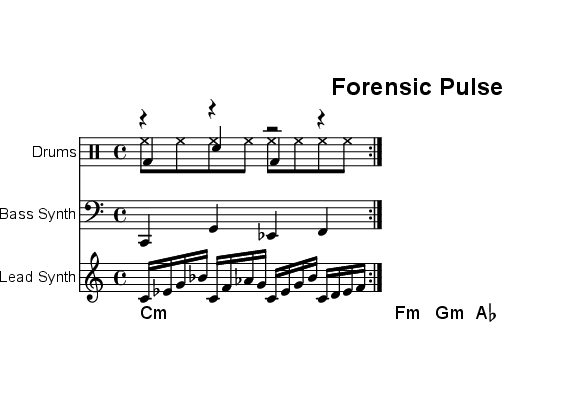What is the key signature of this music? The key signature is C minor, indicated by three flats in the music notation. These flats correspond to the notes B♭, E♭, and A♭. This can be confirmed by looking at the key signature shown at the beginning of the sheet music.
Answer: C minor What is the time signature of this piece? The time signature is 4/4, which means there are four beats in each measure and the quarter note gets one beat. This is straightforwardly indicated at the start of the sheet music.
Answer: 4/4 What is the tempo marking for the composition? The tempo marking is 128 beats per minute (BPM), specified in the tempo line. This indicates a moderately fast tempo, suitable for electronic music genres.
Answer: 128 How many measures does the kick drum part repeat? The kick drum part repeats for a total of two measures as indicated by the "repeat volta 2" notation, which specifies that the sequence within those measures is to be repeated twice.
Answer: 2 What type of synthesizer is used for the lead part? The lead part is played on a lead synth as indicated in the staff labeling. This suggest a prominent role typical for electronic music, where lead synthesizers provide melodies.
Answer: Lead Synth How many different drum elements are there in total? There are three different drum elements (kick drum, hi-hat, and snare), each represented on its own voice line in the drum staff.
Answer: 3 What kind of harmony is represented in the pad synth section? The pad synth section uses minor chords as indicated by the chord labels (c1:m, f:m, g:m, aes), which provide a rich, harmonic background suitable for the minimalism in techno music.
Answer: Minor chords 